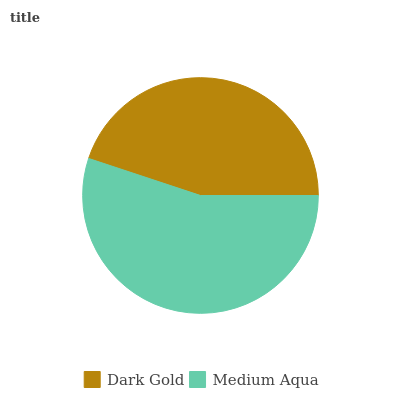Is Dark Gold the minimum?
Answer yes or no. Yes. Is Medium Aqua the maximum?
Answer yes or no. Yes. Is Medium Aqua the minimum?
Answer yes or no. No. Is Medium Aqua greater than Dark Gold?
Answer yes or no. Yes. Is Dark Gold less than Medium Aqua?
Answer yes or no. Yes. Is Dark Gold greater than Medium Aqua?
Answer yes or no. No. Is Medium Aqua less than Dark Gold?
Answer yes or no. No. Is Medium Aqua the high median?
Answer yes or no. Yes. Is Dark Gold the low median?
Answer yes or no. Yes. Is Dark Gold the high median?
Answer yes or no. No. Is Medium Aqua the low median?
Answer yes or no. No. 